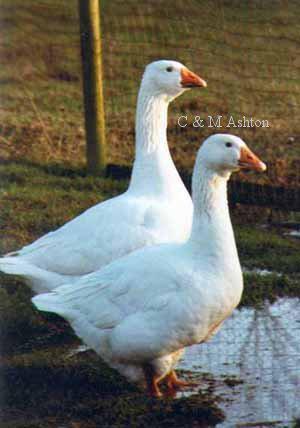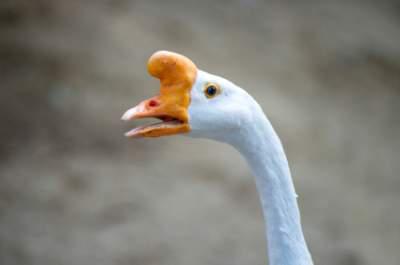The first image is the image on the left, the second image is the image on the right. For the images displayed, is the sentence "There is a single goose in the right image." factually correct? Answer yes or no. Yes. The first image is the image on the left, the second image is the image on the right. For the images shown, is this caption "There are more than ten geese in the images." true? Answer yes or no. No. 